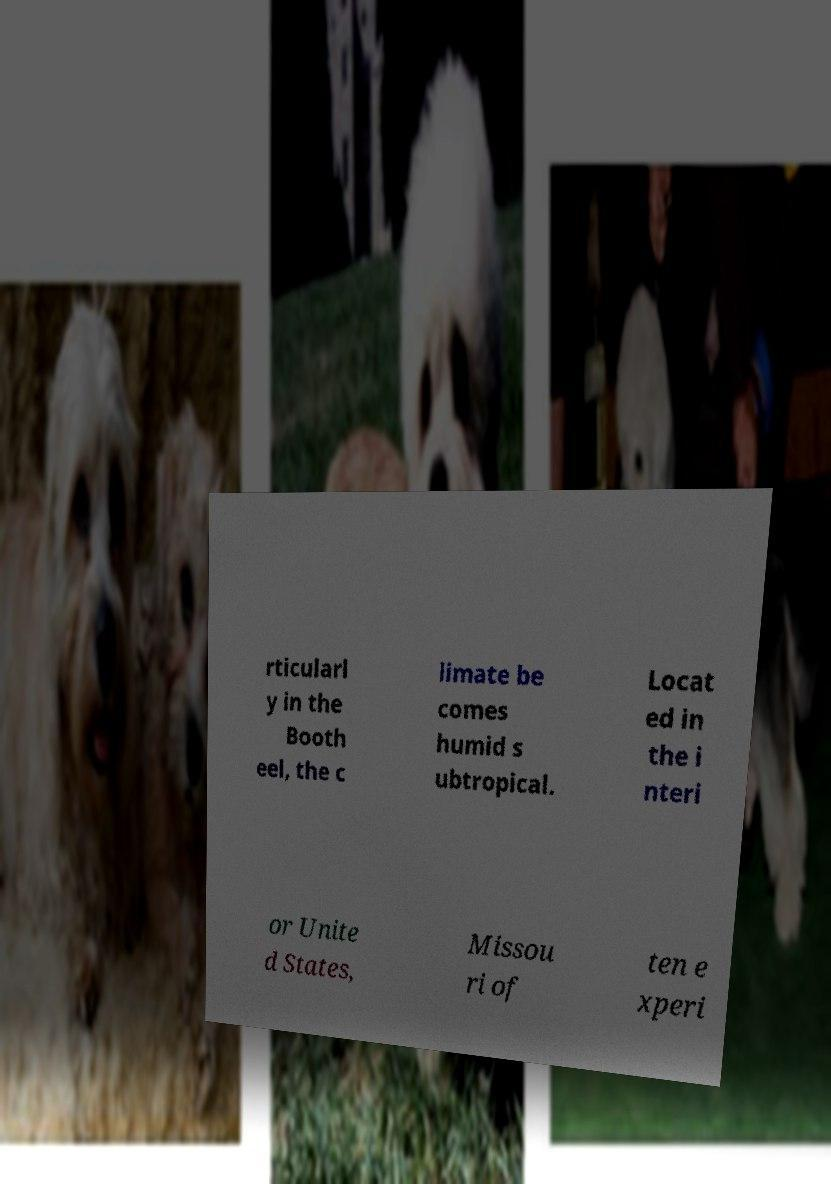I need the written content from this picture converted into text. Can you do that? rticularl y in the Booth eel, the c limate be comes humid s ubtropical. Locat ed in the i nteri or Unite d States, Missou ri of ten e xperi 